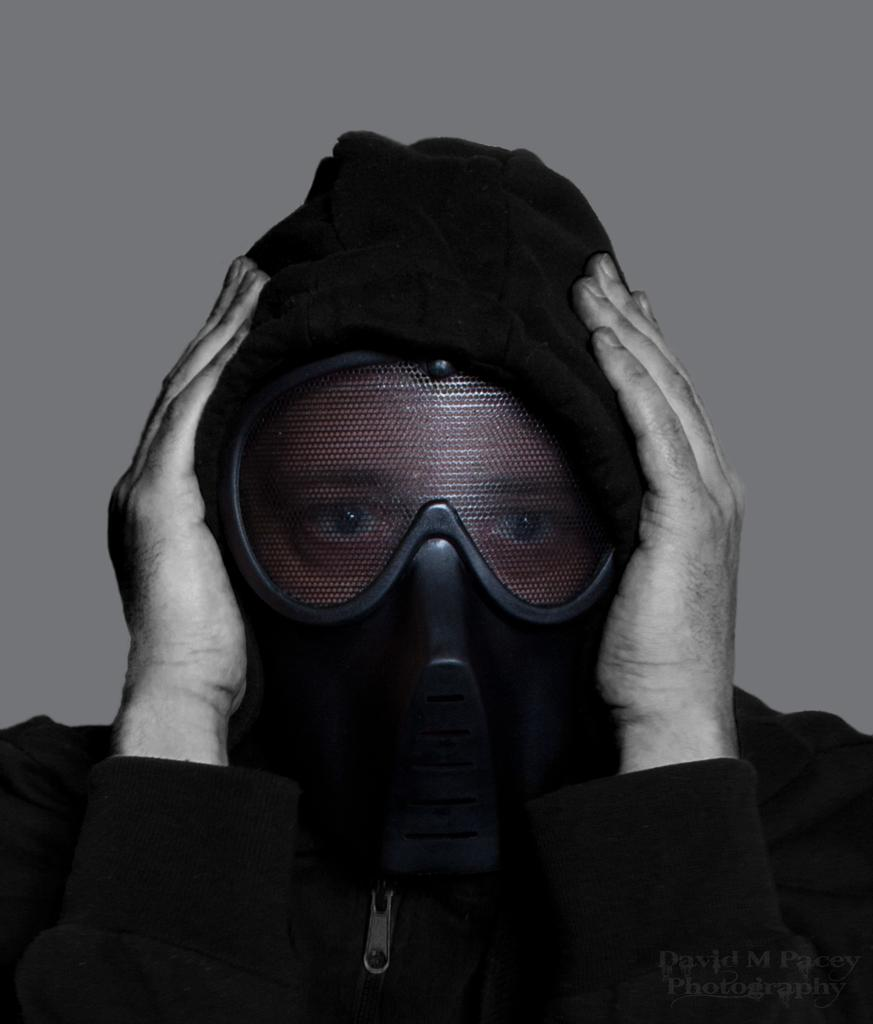Who or what is the main subject in the image? There is a person in the image. What is the person wearing that is visible in the image? The person is wearing a black color jacket and goggles. What can be seen in the background of the image? There is a white color wall in the background of the image. What type of plants can be seen growing on the person's jacket in the image? There are no plants visible on the person's jacket in the image. What event is taking place in the image? There is no specific event depicted in the image; it simply shows a person wearing a black color jacket and goggles in front of a white color wall. 